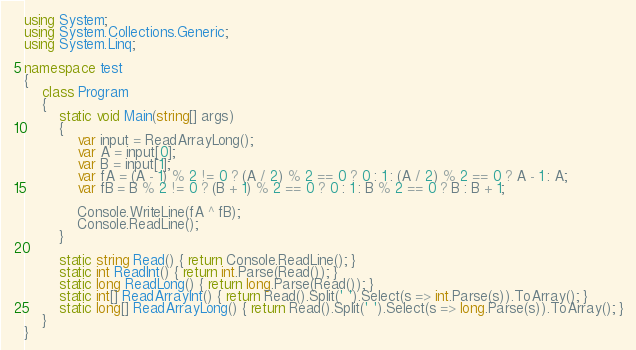Convert code to text. <code><loc_0><loc_0><loc_500><loc_500><_C#_>using System;
using System.Collections.Generic;
using System.Linq;

namespace test
{
    class Program
    {
        static void Main(string[] args)
        {
            var input = ReadArrayLong();
            var A = input[0];
            var B = input[1];
            var fA = (A - 1) % 2 != 0 ? (A / 2) % 2 == 0 ? 0 : 1 : (A / 2) % 2 == 0 ? A - 1 : A;
            var fB = B % 2 != 0 ? (B + 1) % 2 == 0 ? 0 : 1 : B % 2 == 0 ? B : B + 1;

            Console.WriteLine(fA ^ fB);
            Console.ReadLine();
        }

        static string Read() { return Console.ReadLine(); }
        static int ReadInt() { return int.Parse(Read()); }
        static long ReadLong() { return long.Parse(Read()); }
        static int[] ReadArrayInt() { return Read().Split(' ').Select(s => int.Parse(s)).ToArray(); }
        static long[] ReadArrayLong() { return Read().Split(' ').Select(s => long.Parse(s)).ToArray(); }
    }
}</code> 